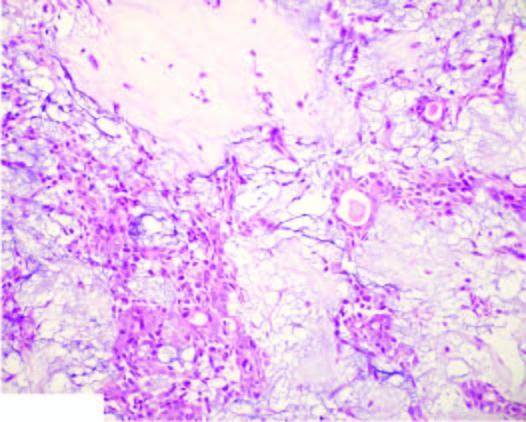s the inner circle shown with green line comprised of ducts, acini, tubules, sheets and strands of cuboidal and myoepithelial cells?
Answer the question using a single word or phrase. No 